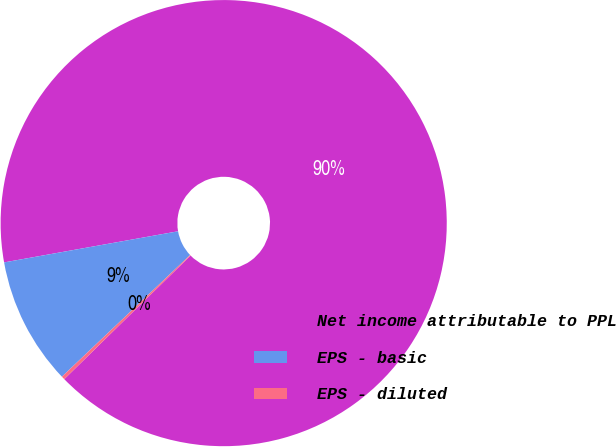<chart> <loc_0><loc_0><loc_500><loc_500><pie_chart><fcel>Net income attributable to PPL<fcel>EPS - basic<fcel>EPS - diluted<nl><fcel>90.49%<fcel>9.27%<fcel>0.24%<nl></chart> 